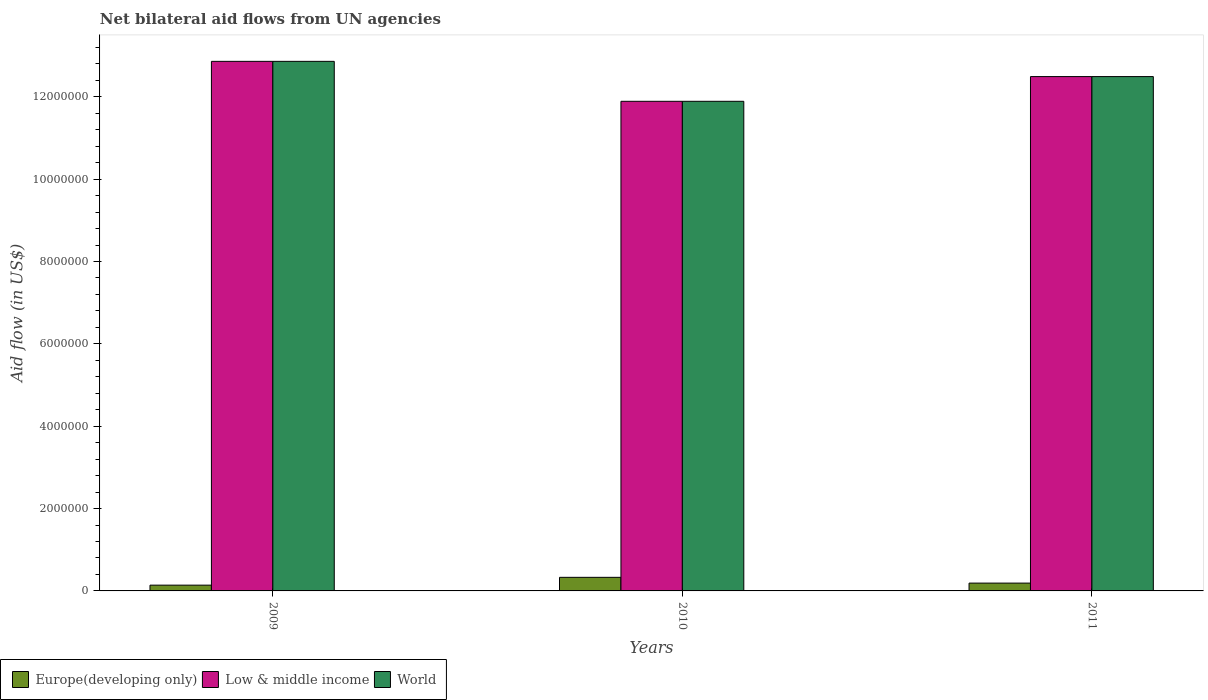How many groups of bars are there?
Your response must be concise. 3. Are the number of bars per tick equal to the number of legend labels?
Provide a short and direct response. Yes. How many bars are there on the 1st tick from the right?
Provide a short and direct response. 3. What is the label of the 3rd group of bars from the left?
Your response must be concise. 2011. What is the net bilateral aid flow in Low & middle income in 2010?
Give a very brief answer. 1.19e+07. Across all years, what is the maximum net bilateral aid flow in World?
Make the answer very short. 1.29e+07. Across all years, what is the minimum net bilateral aid flow in World?
Offer a terse response. 1.19e+07. In which year was the net bilateral aid flow in Europe(developing only) minimum?
Ensure brevity in your answer.  2009. What is the total net bilateral aid flow in Low & middle income in the graph?
Provide a short and direct response. 3.72e+07. What is the difference between the net bilateral aid flow in World in 2010 and that in 2011?
Give a very brief answer. -6.00e+05. What is the difference between the net bilateral aid flow in World in 2011 and the net bilateral aid flow in Europe(developing only) in 2010?
Offer a terse response. 1.22e+07. What is the average net bilateral aid flow in World per year?
Provide a short and direct response. 1.24e+07. In the year 2009, what is the difference between the net bilateral aid flow in Europe(developing only) and net bilateral aid flow in Low & middle income?
Offer a very short reply. -1.27e+07. What is the ratio of the net bilateral aid flow in World in 2010 to that in 2011?
Your response must be concise. 0.95. Is the net bilateral aid flow in Europe(developing only) in 2010 less than that in 2011?
Your response must be concise. No. Is the difference between the net bilateral aid flow in Europe(developing only) in 2010 and 2011 greater than the difference between the net bilateral aid flow in Low & middle income in 2010 and 2011?
Your answer should be compact. Yes. What is the difference between the highest and the lowest net bilateral aid flow in World?
Give a very brief answer. 9.70e+05. In how many years, is the net bilateral aid flow in Low & middle income greater than the average net bilateral aid flow in Low & middle income taken over all years?
Your response must be concise. 2. Is the sum of the net bilateral aid flow in Low & middle income in 2009 and 2010 greater than the maximum net bilateral aid flow in Europe(developing only) across all years?
Offer a terse response. Yes. What does the 1st bar from the left in 2009 represents?
Offer a very short reply. Europe(developing only). What does the 3rd bar from the right in 2010 represents?
Your answer should be compact. Europe(developing only). Are all the bars in the graph horizontal?
Make the answer very short. No. How many years are there in the graph?
Keep it short and to the point. 3. Are the values on the major ticks of Y-axis written in scientific E-notation?
Provide a succinct answer. No. Does the graph contain any zero values?
Keep it short and to the point. No. How many legend labels are there?
Offer a terse response. 3. What is the title of the graph?
Give a very brief answer. Net bilateral aid flows from UN agencies. What is the label or title of the X-axis?
Your response must be concise. Years. What is the label or title of the Y-axis?
Your answer should be very brief. Aid flow (in US$). What is the Aid flow (in US$) of Europe(developing only) in 2009?
Your response must be concise. 1.40e+05. What is the Aid flow (in US$) in Low & middle income in 2009?
Offer a very short reply. 1.29e+07. What is the Aid flow (in US$) of World in 2009?
Your answer should be compact. 1.29e+07. What is the Aid flow (in US$) in Low & middle income in 2010?
Keep it short and to the point. 1.19e+07. What is the Aid flow (in US$) of World in 2010?
Offer a very short reply. 1.19e+07. What is the Aid flow (in US$) of Europe(developing only) in 2011?
Your answer should be compact. 1.90e+05. What is the Aid flow (in US$) in Low & middle income in 2011?
Provide a succinct answer. 1.25e+07. What is the Aid flow (in US$) in World in 2011?
Your answer should be very brief. 1.25e+07. Across all years, what is the maximum Aid flow (in US$) in Europe(developing only)?
Offer a very short reply. 3.30e+05. Across all years, what is the maximum Aid flow (in US$) in Low & middle income?
Your answer should be very brief. 1.29e+07. Across all years, what is the maximum Aid flow (in US$) in World?
Make the answer very short. 1.29e+07. Across all years, what is the minimum Aid flow (in US$) of Europe(developing only)?
Offer a very short reply. 1.40e+05. Across all years, what is the minimum Aid flow (in US$) of Low & middle income?
Offer a terse response. 1.19e+07. Across all years, what is the minimum Aid flow (in US$) in World?
Provide a short and direct response. 1.19e+07. What is the total Aid flow (in US$) of Europe(developing only) in the graph?
Offer a terse response. 6.60e+05. What is the total Aid flow (in US$) of Low & middle income in the graph?
Your answer should be compact. 3.72e+07. What is the total Aid flow (in US$) of World in the graph?
Keep it short and to the point. 3.72e+07. What is the difference between the Aid flow (in US$) of Low & middle income in 2009 and that in 2010?
Provide a succinct answer. 9.70e+05. What is the difference between the Aid flow (in US$) in World in 2009 and that in 2010?
Provide a short and direct response. 9.70e+05. What is the difference between the Aid flow (in US$) in Low & middle income in 2009 and that in 2011?
Your answer should be compact. 3.70e+05. What is the difference between the Aid flow (in US$) in Low & middle income in 2010 and that in 2011?
Offer a terse response. -6.00e+05. What is the difference between the Aid flow (in US$) of World in 2010 and that in 2011?
Your answer should be very brief. -6.00e+05. What is the difference between the Aid flow (in US$) in Europe(developing only) in 2009 and the Aid flow (in US$) in Low & middle income in 2010?
Make the answer very short. -1.18e+07. What is the difference between the Aid flow (in US$) of Europe(developing only) in 2009 and the Aid flow (in US$) of World in 2010?
Your response must be concise. -1.18e+07. What is the difference between the Aid flow (in US$) of Low & middle income in 2009 and the Aid flow (in US$) of World in 2010?
Offer a terse response. 9.70e+05. What is the difference between the Aid flow (in US$) in Europe(developing only) in 2009 and the Aid flow (in US$) in Low & middle income in 2011?
Ensure brevity in your answer.  -1.24e+07. What is the difference between the Aid flow (in US$) in Europe(developing only) in 2009 and the Aid flow (in US$) in World in 2011?
Your answer should be very brief. -1.24e+07. What is the difference between the Aid flow (in US$) of Europe(developing only) in 2010 and the Aid flow (in US$) of Low & middle income in 2011?
Offer a very short reply. -1.22e+07. What is the difference between the Aid flow (in US$) in Europe(developing only) in 2010 and the Aid flow (in US$) in World in 2011?
Offer a very short reply. -1.22e+07. What is the difference between the Aid flow (in US$) of Low & middle income in 2010 and the Aid flow (in US$) of World in 2011?
Offer a terse response. -6.00e+05. What is the average Aid flow (in US$) of Low & middle income per year?
Your response must be concise. 1.24e+07. What is the average Aid flow (in US$) of World per year?
Offer a very short reply. 1.24e+07. In the year 2009, what is the difference between the Aid flow (in US$) in Europe(developing only) and Aid flow (in US$) in Low & middle income?
Offer a very short reply. -1.27e+07. In the year 2009, what is the difference between the Aid flow (in US$) of Europe(developing only) and Aid flow (in US$) of World?
Make the answer very short. -1.27e+07. In the year 2009, what is the difference between the Aid flow (in US$) of Low & middle income and Aid flow (in US$) of World?
Provide a succinct answer. 0. In the year 2010, what is the difference between the Aid flow (in US$) in Europe(developing only) and Aid flow (in US$) in Low & middle income?
Provide a succinct answer. -1.16e+07. In the year 2010, what is the difference between the Aid flow (in US$) of Europe(developing only) and Aid flow (in US$) of World?
Make the answer very short. -1.16e+07. In the year 2010, what is the difference between the Aid flow (in US$) of Low & middle income and Aid flow (in US$) of World?
Offer a terse response. 0. In the year 2011, what is the difference between the Aid flow (in US$) of Europe(developing only) and Aid flow (in US$) of Low & middle income?
Offer a very short reply. -1.23e+07. In the year 2011, what is the difference between the Aid flow (in US$) in Europe(developing only) and Aid flow (in US$) in World?
Provide a succinct answer. -1.23e+07. In the year 2011, what is the difference between the Aid flow (in US$) in Low & middle income and Aid flow (in US$) in World?
Ensure brevity in your answer.  0. What is the ratio of the Aid flow (in US$) in Europe(developing only) in 2009 to that in 2010?
Your answer should be very brief. 0.42. What is the ratio of the Aid flow (in US$) in Low & middle income in 2009 to that in 2010?
Offer a terse response. 1.08. What is the ratio of the Aid flow (in US$) of World in 2009 to that in 2010?
Provide a short and direct response. 1.08. What is the ratio of the Aid flow (in US$) in Europe(developing only) in 2009 to that in 2011?
Ensure brevity in your answer.  0.74. What is the ratio of the Aid flow (in US$) of Low & middle income in 2009 to that in 2011?
Your answer should be very brief. 1.03. What is the ratio of the Aid flow (in US$) of World in 2009 to that in 2011?
Your answer should be compact. 1.03. What is the ratio of the Aid flow (in US$) in Europe(developing only) in 2010 to that in 2011?
Provide a short and direct response. 1.74. What is the ratio of the Aid flow (in US$) in World in 2010 to that in 2011?
Offer a terse response. 0.95. What is the difference between the highest and the second highest Aid flow (in US$) of Low & middle income?
Keep it short and to the point. 3.70e+05. What is the difference between the highest and the second highest Aid flow (in US$) in World?
Keep it short and to the point. 3.70e+05. What is the difference between the highest and the lowest Aid flow (in US$) in Europe(developing only)?
Keep it short and to the point. 1.90e+05. What is the difference between the highest and the lowest Aid flow (in US$) in Low & middle income?
Ensure brevity in your answer.  9.70e+05. What is the difference between the highest and the lowest Aid flow (in US$) in World?
Keep it short and to the point. 9.70e+05. 